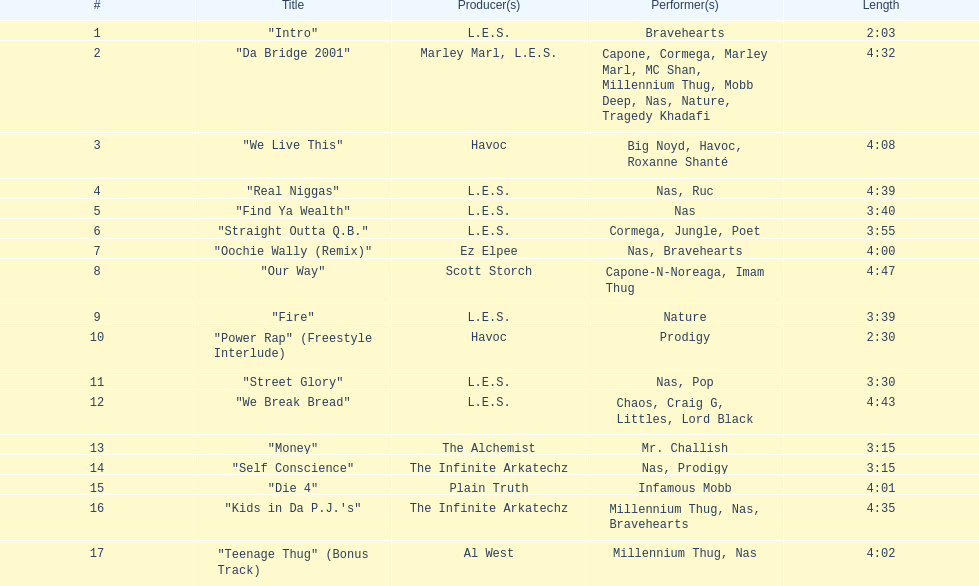Which track is longer, "money" or "die 4"? "Die 4". 